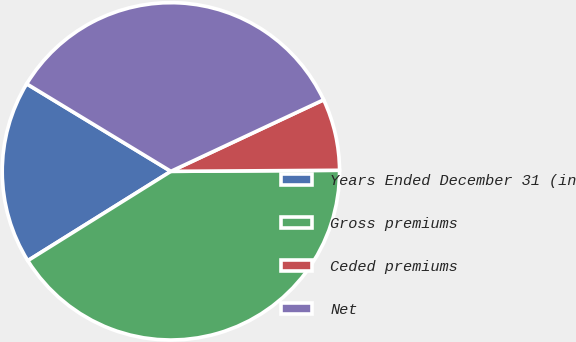Convert chart to OTSL. <chart><loc_0><loc_0><loc_500><loc_500><pie_chart><fcel>Years Ended December 31 (in<fcel>Gross premiums<fcel>Ceded premiums<fcel>Net<nl><fcel>17.56%<fcel>41.22%<fcel>6.87%<fcel>34.35%<nl></chart> 